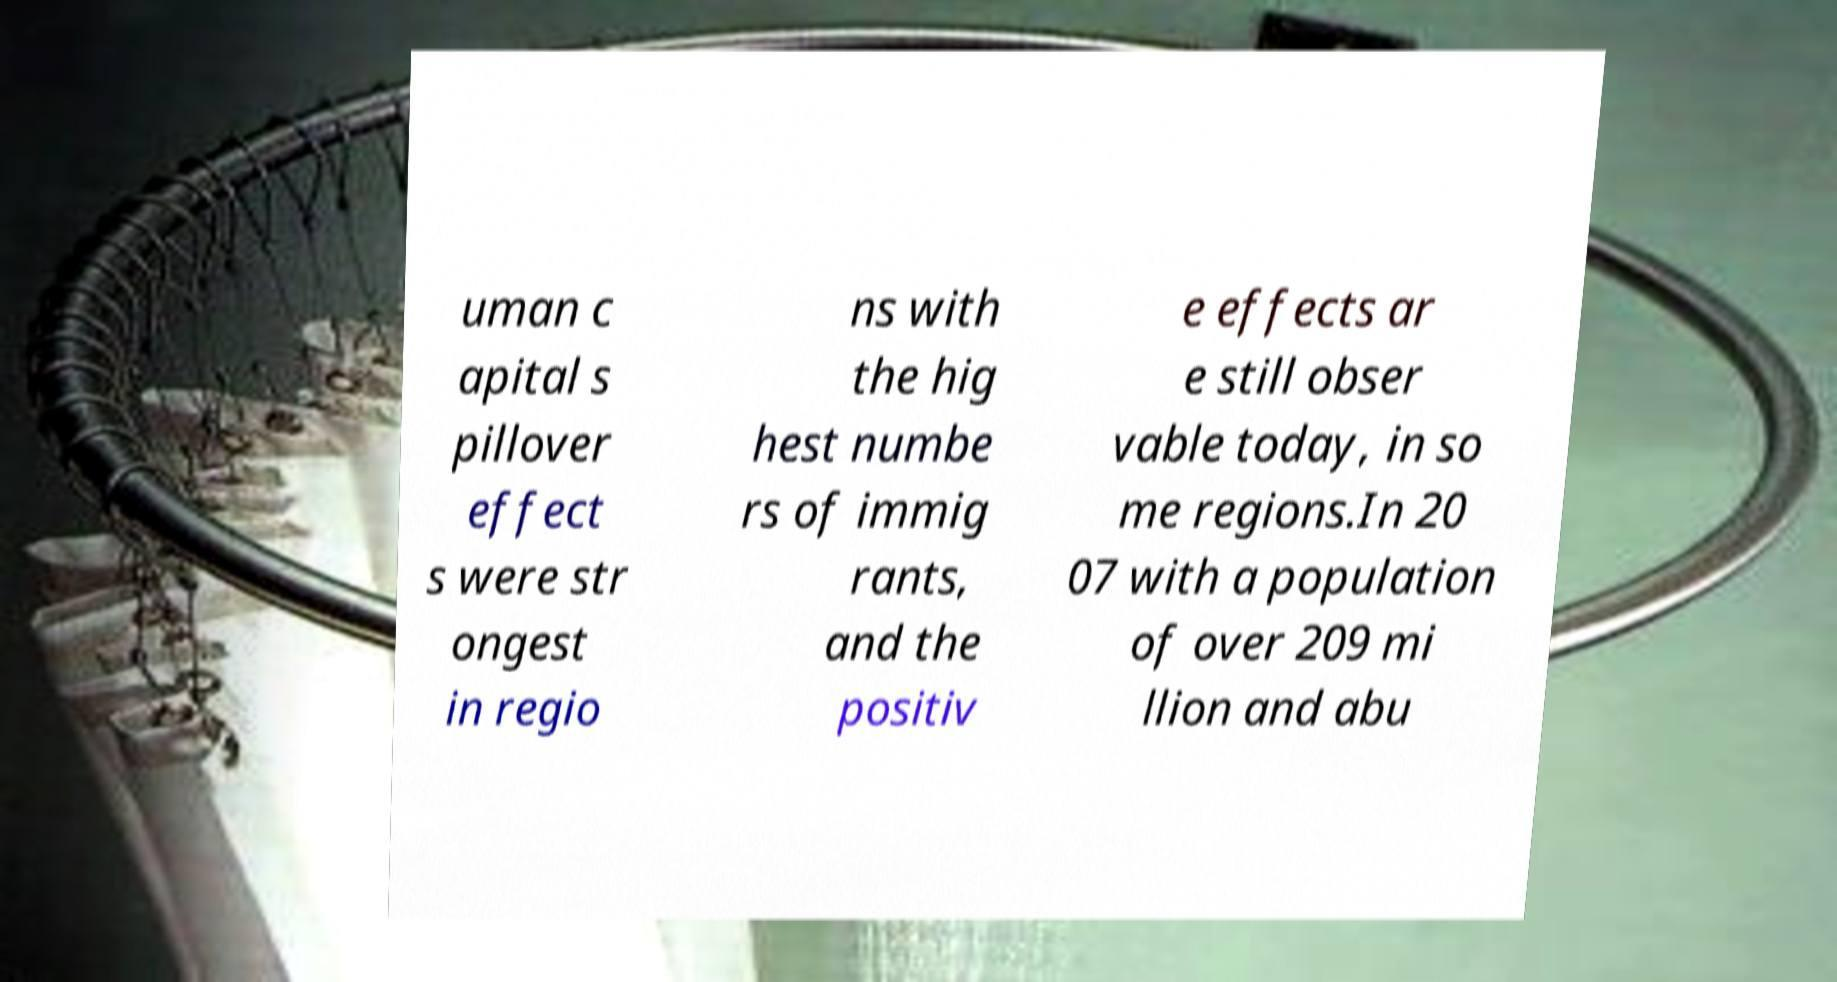Can you accurately transcribe the text from the provided image for me? uman c apital s pillover effect s were str ongest in regio ns with the hig hest numbe rs of immig rants, and the positiv e effects ar e still obser vable today, in so me regions.In 20 07 with a population of over 209 mi llion and abu 